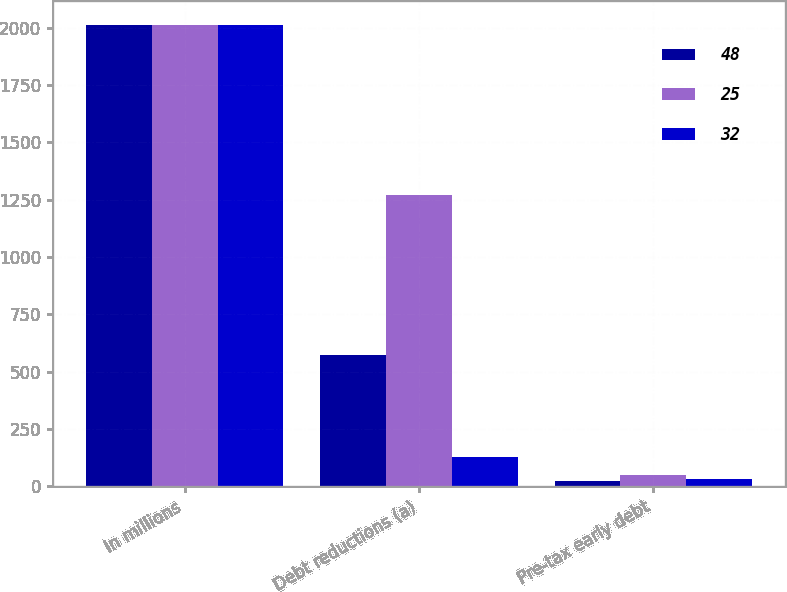<chart> <loc_0><loc_0><loc_500><loc_500><stacked_bar_chart><ecel><fcel>In millions<fcel>Debt reductions (a)<fcel>Pre-tax early debt<nl><fcel>48<fcel>2013<fcel>574<fcel>25<nl><fcel>25<fcel>2012<fcel>1272<fcel>48<nl><fcel>32<fcel>2011<fcel>129<fcel>32<nl></chart> 